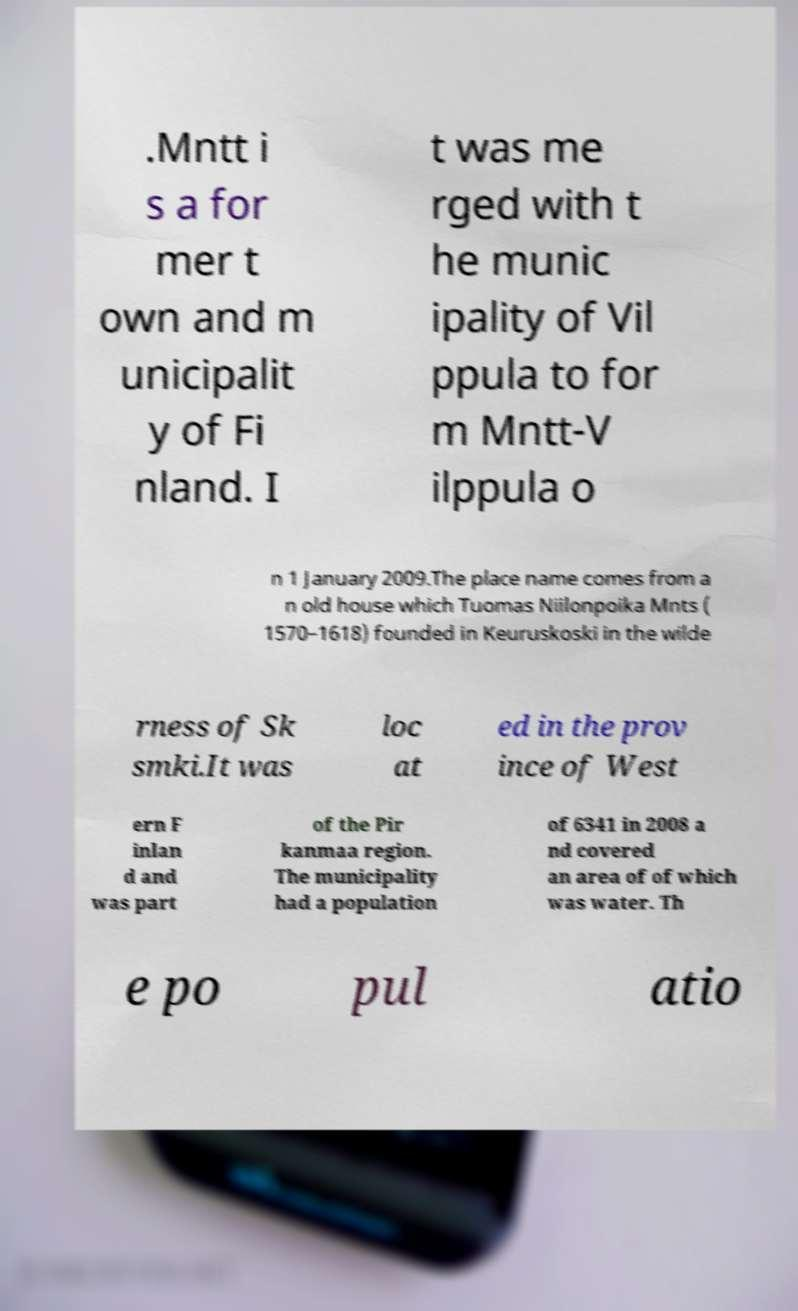Could you extract and type out the text from this image? .Mntt i s a for mer t own and m unicipalit y of Fi nland. I t was me rged with t he munic ipality of Vil ppula to for m Mntt-V ilppula o n 1 January 2009.The place name comes from a n old house which Tuomas Niilonpoika Mnts ( 1570–1618) founded in Keuruskoski in the wilde rness of Sk smki.It was loc at ed in the prov ince of West ern F inlan d and was part of the Pir kanmaa region. The municipality had a population of 6341 in 2008 a nd covered an area of of which was water. Th e po pul atio 